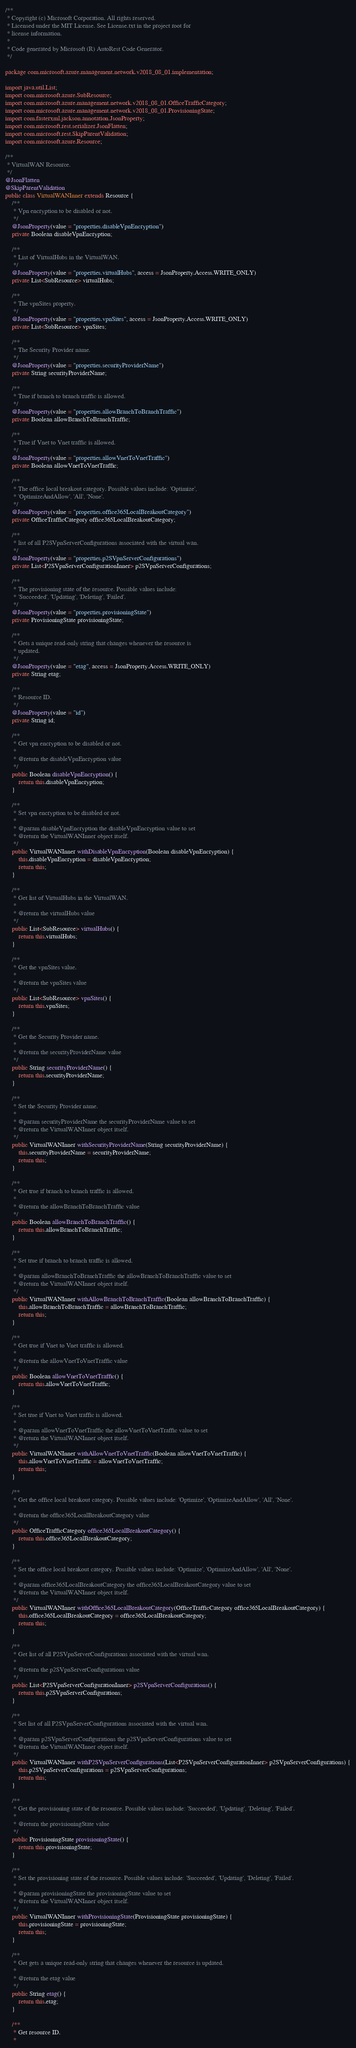Convert code to text. <code><loc_0><loc_0><loc_500><loc_500><_Java_>/**
 * Copyright (c) Microsoft Corporation. All rights reserved.
 * Licensed under the MIT License. See License.txt in the project root for
 * license information.
 *
 * Code generated by Microsoft (R) AutoRest Code Generator.
 */

package com.microsoft.azure.management.network.v2018_08_01.implementation;

import java.util.List;
import com.microsoft.azure.SubResource;
import com.microsoft.azure.management.network.v2018_08_01.OfficeTrafficCategory;
import com.microsoft.azure.management.network.v2018_08_01.ProvisioningState;
import com.fasterxml.jackson.annotation.JsonProperty;
import com.microsoft.rest.serializer.JsonFlatten;
import com.microsoft.rest.SkipParentValidation;
import com.microsoft.azure.Resource;

/**
 * VirtualWAN Resource.
 */
@JsonFlatten
@SkipParentValidation
public class VirtualWANInner extends Resource {
    /**
     * Vpn encryption to be disabled or not.
     */
    @JsonProperty(value = "properties.disableVpnEncryption")
    private Boolean disableVpnEncryption;

    /**
     * List of VirtualHubs in the VirtualWAN.
     */
    @JsonProperty(value = "properties.virtualHubs", access = JsonProperty.Access.WRITE_ONLY)
    private List<SubResource> virtualHubs;

    /**
     * The vpnSites property.
     */
    @JsonProperty(value = "properties.vpnSites", access = JsonProperty.Access.WRITE_ONLY)
    private List<SubResource> vpnSites;

    /**
     * The Security Provider name.
     */
    @JsonProperty(value = "properties.securityProviderName")
    private String securityProviderName;

    /**
     * True if branch to branch traffic is allowed.
     */
    @JsonProperty(value = "properties.allowBranchToBranchTraffic")
    private Boolean allowBranchToBranchTraffic;

    /**
     * True if Vnet to Vnet traffic is allowed.
     */
    @JsonProperty(value = "properties.allowVnetToVnetTraffic")
    private Boolean allowVnetToVnetTraffic;

    /**
     * The office local breakout category. Possible values include: 'Optimize',
     * 'OptimizeAndAllow', 'All', 'None'.
     */
    @JsonProperty(value = "properties.office365LocalBreakoutCategory")
    private OfficeTrafficCategory office365LocalBreakoutCategory;

    /**
     * list of all P2SVpnServerConfigurations associated with the virtual wan.
     */
    @JsonProperty(value = "properties.p2SVpnServerConfigurations")
    private List<P2SVpnServerConfigurationInner> p2SVpnServerConfigurations;

    /**
     * The provisioning state of the resource. Possible values include:
     * 'Succeeded', 'Updating', 'Deleting', 'Failed'.
     */
    @JsonProperty(value = "properties.provisioningState")
    private ProvisioningState provisioningState;

    /**
     * Gets a unique read-only string that changes whenever the resource is
     * updated.
     */
    @JsonProperty(value = "etag", access = JsonProperty.Access.WRITE_ONLY)
    private String etag;

    /**
     * Resource ID.
     */
    @JsonProperty(value = "id")
    private String id;

    /**
     * Get vpn encryption to be disabled or not.
     *
     * @return the disableVpnEncryption value
     */
    public Boolean disableVpnEncryption() {
        return this.disableVpnEncryption;
    }

    /**
     * Set vpn encryption to be disabled or not.
     *
     * @param disableVpnEncryption the disableVpnEncryption value to set
     * @return the VirtualWANInner object itself.
     */
    public VirtualWANInner withDisableVpnEncryption(Boolean disableVpnEncryption) {
        this.disableVpnEncryption = disableVpnEncryption;
        return this;
    }

    /**
     * Get list of VirtualHubs in the VirtualWAN.
     *
     * @return the virtualHubs value
     */
    public List<SubResource> virtualHubs() {
        return this.virtualHubs;
    }

    /**
     * Get the vpnSites value.
     *
     * @return the vpnSites value
     */
    public List<SubResource> vpnSites() {
        return this.vpnSites;
    }

    /**
     * Get the Security Provider name.
     *
     * @return the securityProviderName value
     */
    public String securityProviderName() {
        return this.securityProviderName;
    }

    /**
     * Set the Security Provider name.
     *
     * @param securityProviderName the securityProviderName value to set
     * @return the VirtualWANInner object itself.
     */
    public VirtualWANInner withSecurityProviderName(String securityProviderName) {
        this.securityProviderName = securityProviderName;
        return this;
    }

    /**
     * Get true if branch to branch traffic is allowed.
     *
     * @return the allowBranchToBranchTraffic value
     */
    public Boolean allowBranchToBranchTraffic() {
        return this.allowBranchToBranchTraffic;
    }

    /**
     * Set true if branch to branch traffic is allowed.
     *
     * @param allowBranchToBranchTraffic the allowBranchToBranchTraffic value to set
     * @return the VirtualWANInner object itself.
     */
    public VirtualWANInner withAllowBranchToBranchTraffic(Boolean allowBranchToBranchTraffic) {
        this.allowBranchToBranchTraffic = allowBranchToBranchTraffic;
        return this;
    }

    /**
     * Get true if Vnet to Vnet traffic is allowed.
     *
     * @return the allowVnetToVnetTraffic value
     */
    public Boolean allowVnetToVnetTraffic() {
        return this.allowVnetToVnetTraffic;
    }

    /**
     * Set true if Vnet to Vnet traffic is allowed.
     *
     * @param allowVnetToVnetTraffic the allowVnetToVnetTraffic value to set
     * @return the VirtualWANInner object itself.
     */
    public VirtualWANInner withAllowVnetToVnetTraffic(Boolean allowVnetToVnetTraffic) {
        this.allowVnetToVnetTraffic = allowVnetToVnetTraffic;
        return this;
    }

    /**
     * Get the office local breakout category. Possible values include: 'Optimize', 'OptimizeAndAllow', 'All', 'None'.
     *
     * @return the office365LocalBreakoutCategory value
     */
    public OfficeTrafficCategory office365LocalBreakoutCategory() {
        return this.office365LocalBreakoutCategory;
    }

    /**
     * Set the office local breakout category. Possible values include: 'Optimize', 'OptimizeAndAllow', 'All', 'None'.
     *
     * @param office365LocalBreakoutCategory the office365LocalBreakoutCategory value to set
     * @return the VirtualWANInner object itself.
     */
    public VirtualWANInner withOffice365LocalBreakoutCategory(OfficeTrafficCategory office365LocalBreakoutCategory) {
        this.office365LocalBreakoutCategory = office365LocalBreakoutCategory;
        return this;
    }

    /**
     * Get list of all P2SVpnServerConfigurations associated with the virtual wan.
     *
     * @return the p2SVpnServerConfigurations value
     */
    public List<P2SVpnServerConfigurationInner> p2SVpnServerConfigurations() {
        return this.p2SVpnServerConfigurations;
    }

    /**
     * Set list of all P2SVpnServerConfigurations associated with the virtual wan.
     *
     * @param p2SVpnServerConfigurations the p2SVpnServerConfigurations value to set
     * @return the VirtualWANInner object itself.
     */
    public VirtualWANInner withP2SVpnServerConfigurations(List<P2SVpnServerConfigurationInner> p2SVpnServerConfigurations) {
        this.p2SVpnServerConfigurations = p2SVpnServerConfigurations;
        return this;
    }

    /**
     * Get the provisioning state of the resource. Possible values include: 'Succeeded', 'Updating', 'Deleting', 'Failed'.
     *
     * @return the provisioningState value
     */
    public ProvisioningState provisioningState() {
        return this.provisioningState;
    }

    /**
     * Set the provisioning state of the resource. Possible values include: 'Succeeded', 'Updating', 'Deleting', 'Failed'.
     *
     * @param provisioningState the provisioningState value to set
     * @return the VirtualWANInner object itself.
     */
    public VirtualWANInner withProvisioningState(ProvisioningState provisioningState) {
        this.provisioningState = provisioningState;
        return this;
    }

    /**
     * Get gets a unique read-only string that changes whenever the resource is updated.
     *
     * @return the etag value
     */
    public String etag() {
        return this.etag;
    }

    /**
     * Get resource ID.
     *</code> 